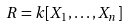<formula> <loc_0><loc_0><loc_500><loc_500>R = k [ X _ { 1 } , \dots , X _ { n } ]</formula> 